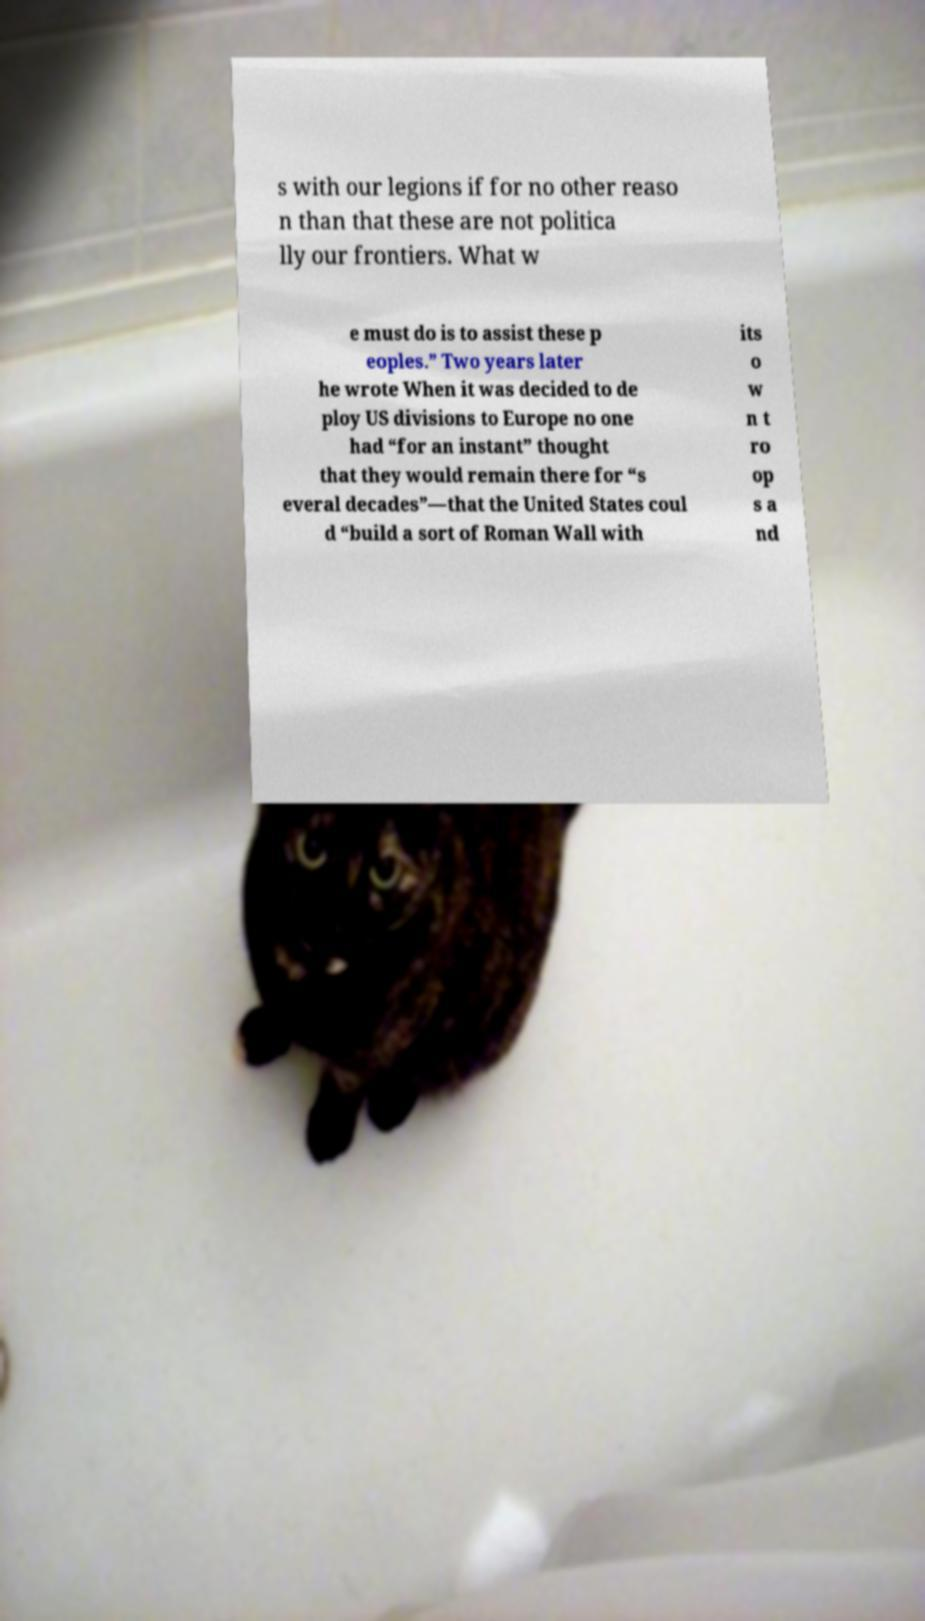Please identify and transcribe the text found in this image. s with our legions if for no other reaso n than that these are not politica lly our frontiers. What w e must do is to assist these p eoples.” Two years later he wrote When it was decided to de ploy US divisions to Europe no one had “for an instant” thought that they would remain there for “s everal decades”—that the United States coul d “build a sort of Roman Wall with its o w n t ro op s a nd 